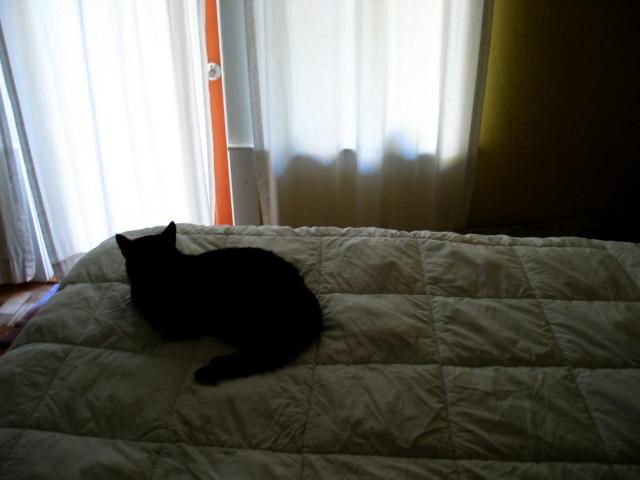What is the cat lying on?
Quick response, please. Bed. Is it uncovered?
Answer briefly. Yes. What color are the drapes?
Be succinct. White. Is the cat asleep?
Keep it brief. No. Is the bed made?
Short answer required. Yes. Where the cat's head?
Write a very short answer. Bed. Is this a dog?
Be succinct. No. What is providing light in the room?
Concise answer only. Window. What kind of cat is this?
Answer briefly. Black. What is this kitty doing?
Keep it brief. Laying on bed. Is the cat on a window sill?
Concise answer only. No. 